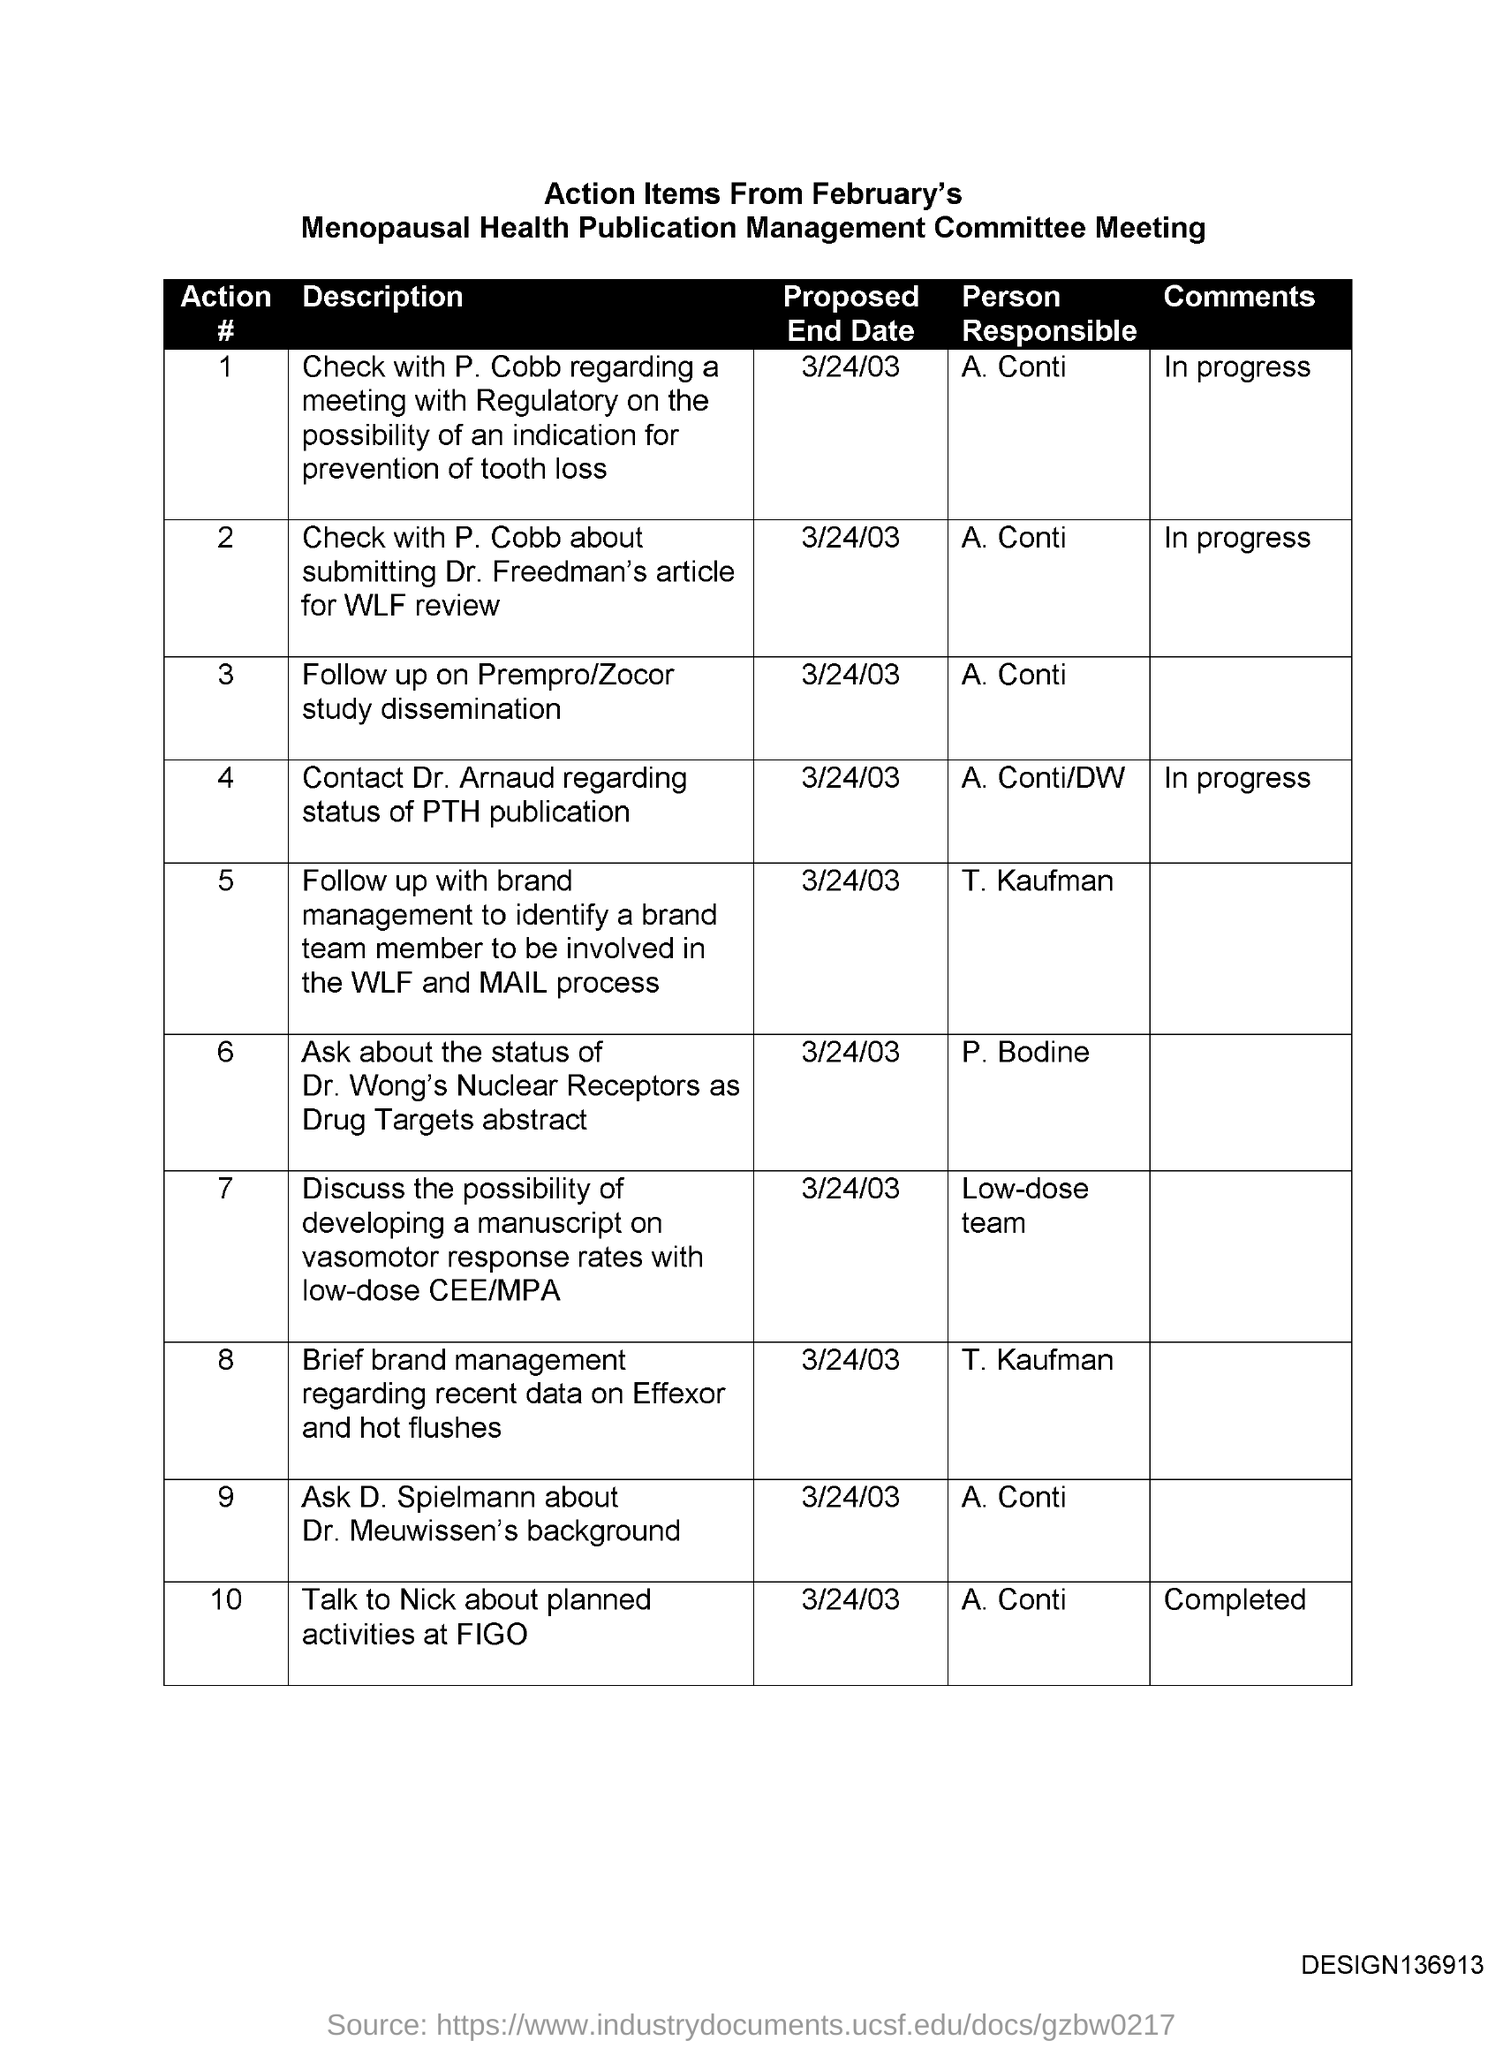Mention a couple of crucial points in this snapshot. The proposed end date for Action #5 is March 24, 2003. The proposed end date for Action #1 is March 24, 2003. The proposed end date for Action #2 is March 24, 2003. The proposed end date for Action #4 is March 24, 2003. The proposed end date for Action #3 is March 24, 2003. 